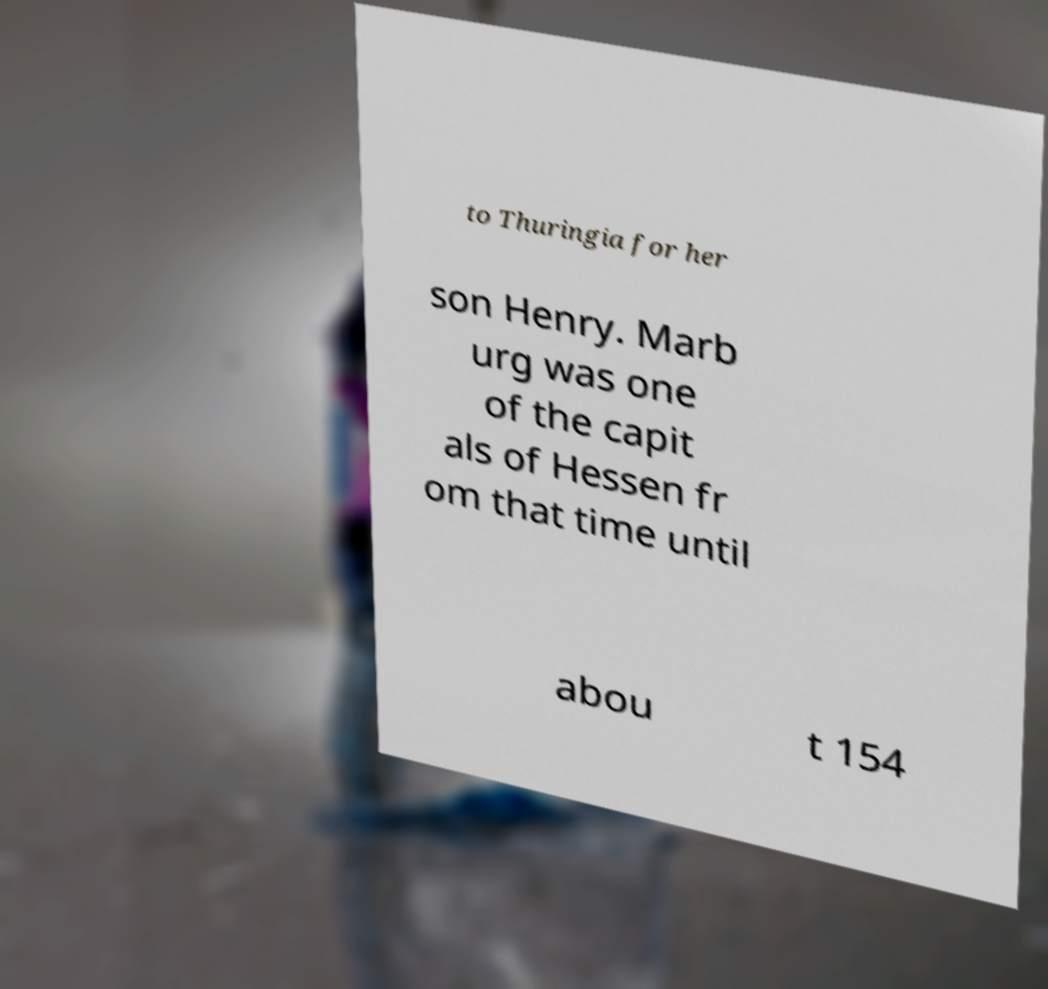Can you accurately transcribe the text from the provided image for me? to Thuringia for her son Henry. Marb urg was one of the capit als of Hessen fr om that time until abou t 154 